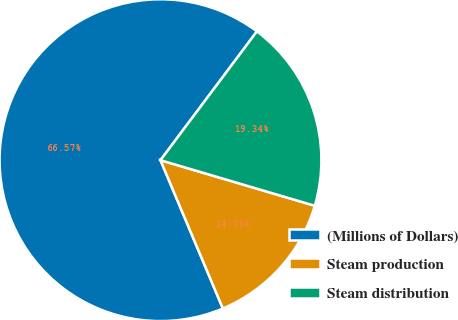Convert chart. <chart><loc_0><loc_0><loc_500><loc_500><pie_chart><fcel>(Millions of Dollars)<fcel>Steam production<fcel>Steam distribution<nl><fcel>66.57%<fcel>14.09%<fcel>19.34%<nl></chart> 